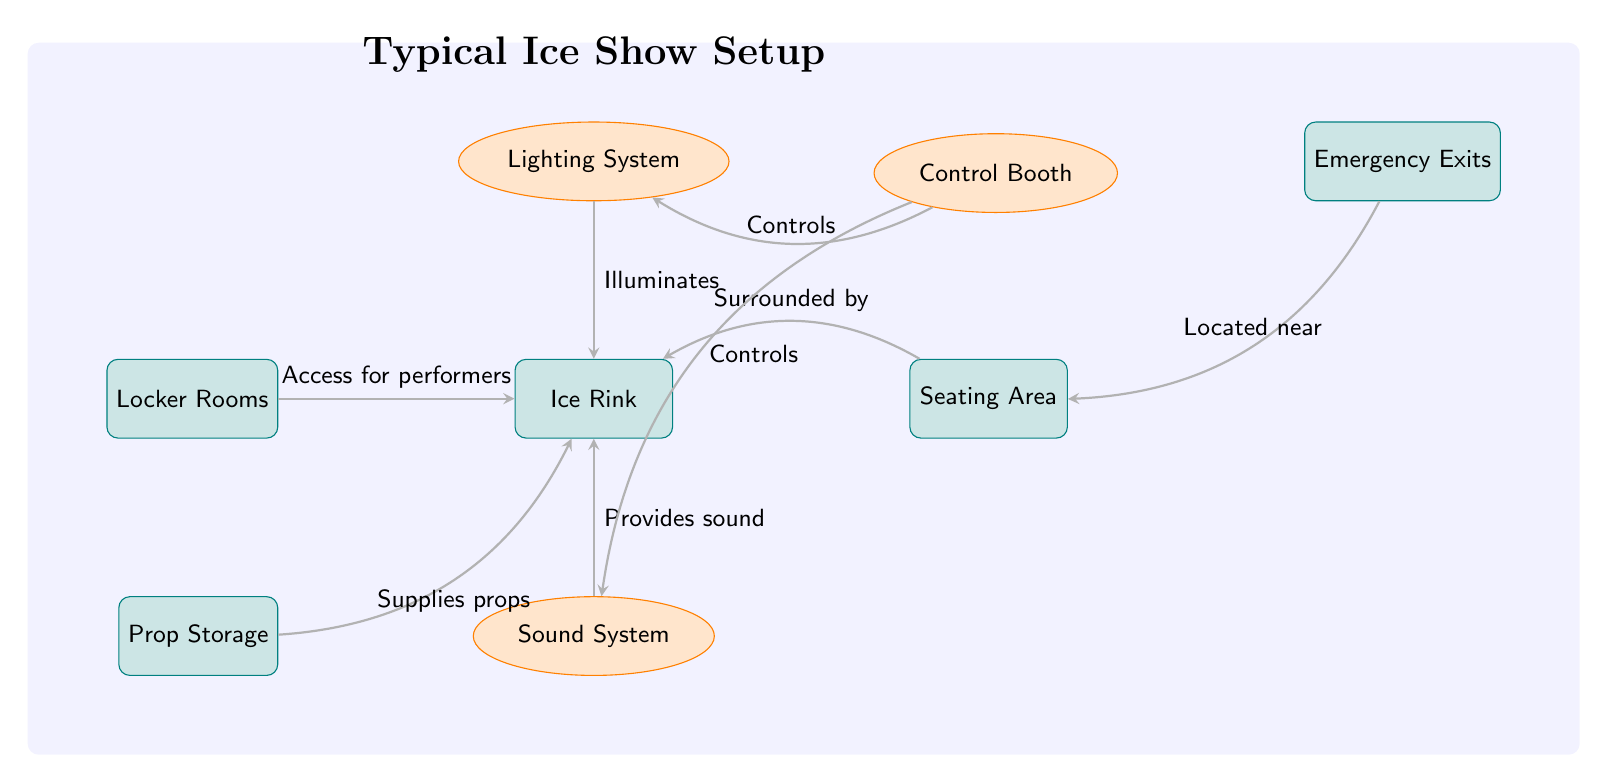What's the primary area in the diagram? The primary area is labeled as "Ice Rink." It is centrally located and serves as the main performance area for ice shows.
Answer: Ice Rink How many equipment nodes are there in the diagram? There are three equipment nodes: Lighting System, Sound System, and Control Booth. Counting these nodes gives a total of three.
Answer: 3 What is located above the ice rink? The node that is located above the ice rink is the "Lighting System," which is positioned to provide illumination for the performance.
Answer: Lighting System Which area provides access for performers? The area that provides access for performers is labeled "Locker Rooms," located to the left of the ice rink, facilitating easy entry for skaters before and after performances.
Answer: Locker Rooms What does the Control Booth control? The Control Booth controls both the Lighting System and the Sound System, as indicated by the connections drawn from it to these equipment nodes with respective labels.
Answer: Lighting System and Sound System Which area is surrounded by the seating area? The area that is surrounded by the seating area is the "Ice Rink," suggesting that the audience sits around this central performance space.
Answer: Ice Rink Where are the emergency exits located in relation to the seating area? The emergency exits are located above right of the seating area, ensuring safety and quick access for the audience in case of an emergency.
Answer: Above right What supplies props to the ice rink? "Prop Storage" is the designated area that supplies props to the ice rink, as indicated by the directional connection labeled "Supplies props."
Answer: Prop Storage How does the Sound System interact with the Ice Rink? The Sound System provides sound to the Ice Rink, indicated by the direct connection between these two nodes labeled "Provides sound."
Answer: Provides sound 